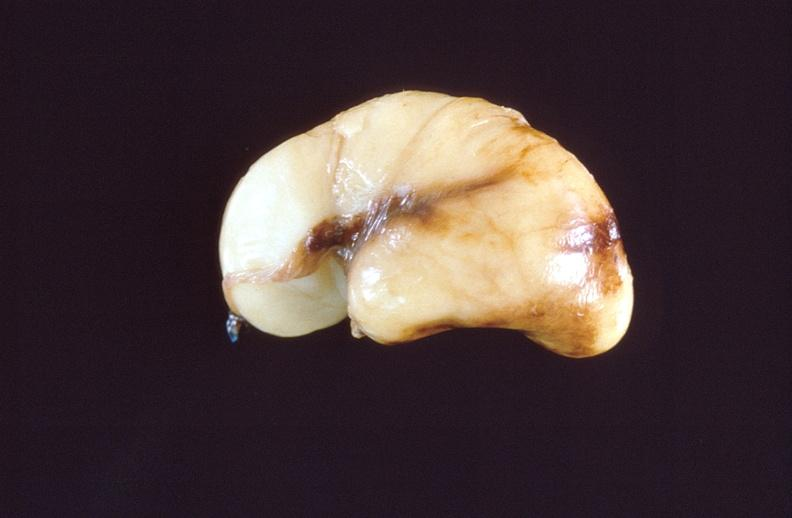does this image show intraventricular hemorrhage, neonate brain?
Answer the question using a single word or phrase. Yes 